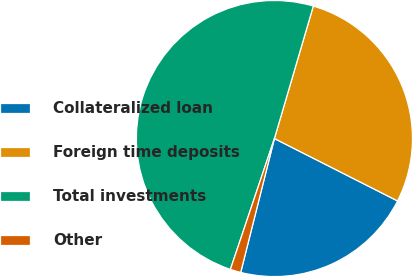Convert chart. <chart><loc_0><loc_0><loc_500><loc_500><pie_chart><fcel>Collateralized loan<fcel>Foreign time deposits<fcel>Total investments<fcel>Other<nl><fcel>21.46%<fcel>27.92%<fcel>49.38%<fcel>1.24%<nl></chart> 